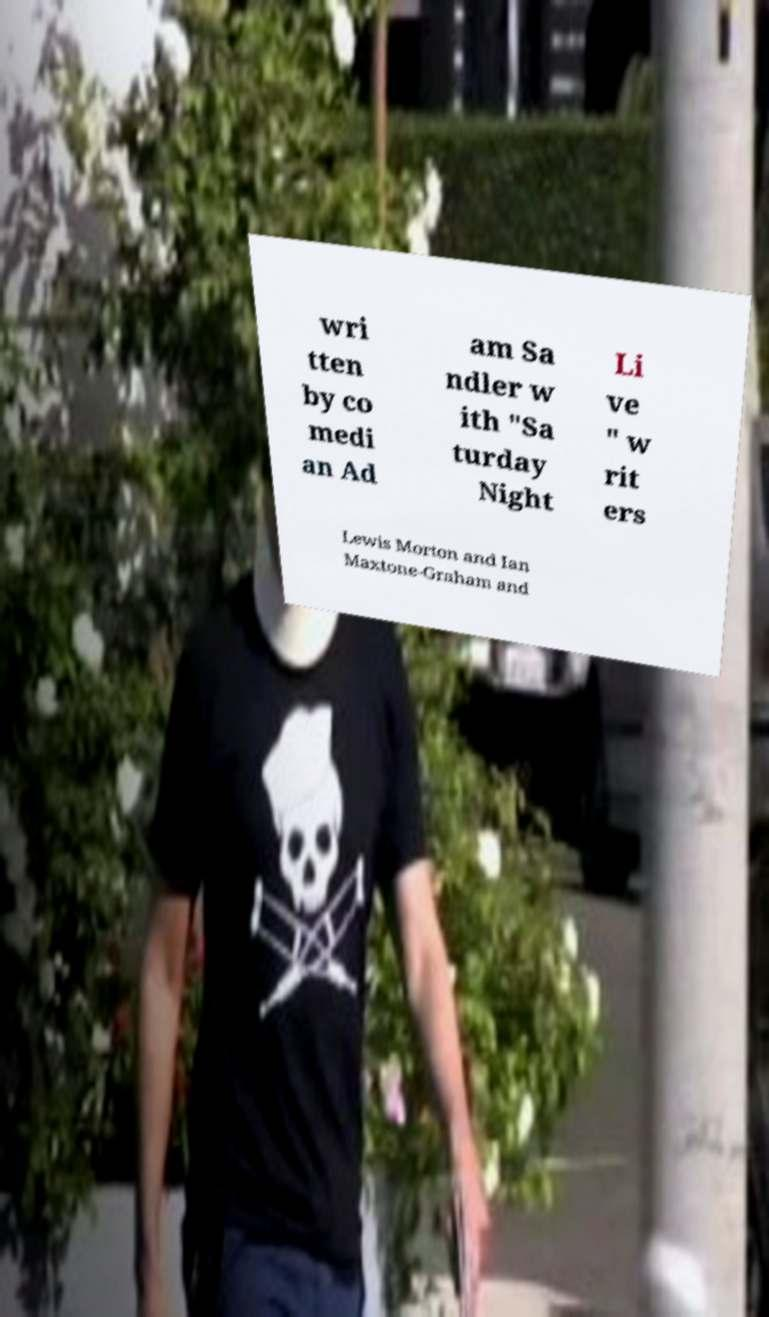Please read and relay the text visible in this image. What does it say? wri tten by co medi an Ad am Sa ndler w ith "Sa turday Night Li ve " w rit ers Lewis Morton and Ian Maxtone-Graham and 